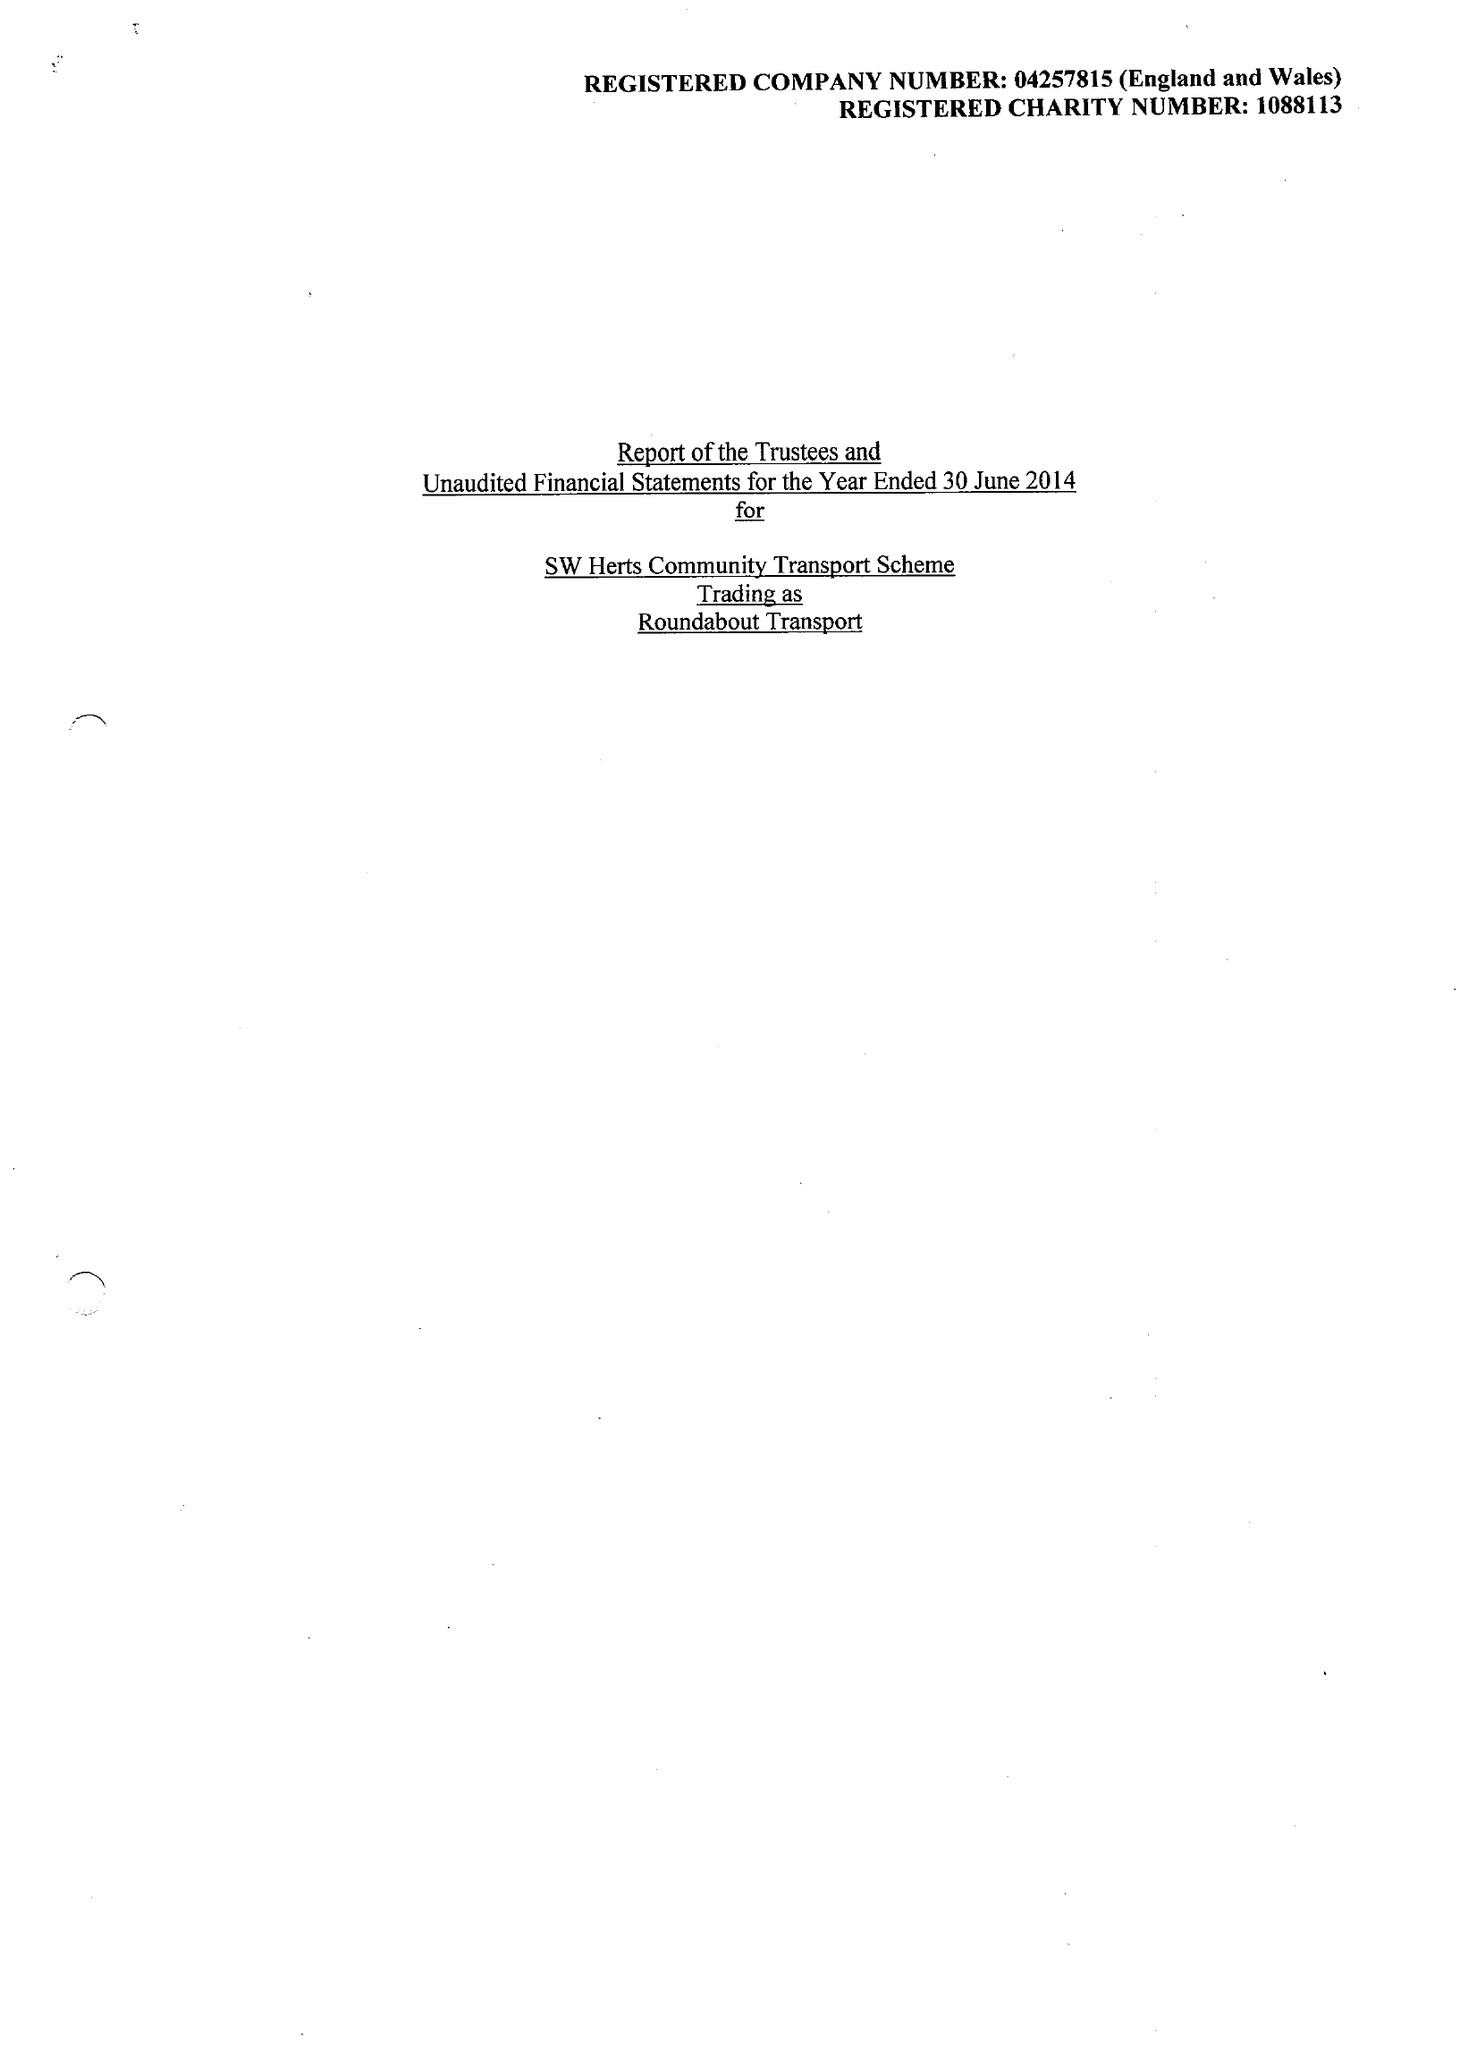What is the value for the charity_name?
Answer the question using a single word or phrase. Sw Herts Community Transport Scheme 